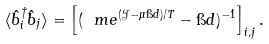<formula> <loc_0><loc_0><loc_500><loc_500>\langle \hat { b } _ { i } ^ { \dagger } \hat { b } _ { j } \rangle = \left [ ( \ m e ^ { ( \mathcal { J } - \mu \i d ) / T } - \i d ) ^ { - 1 } \right ] _ { i , j } .</formula> 